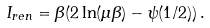<formula> <loc_0><loc_0><loc_500><loc_500>I _ { r e n } = \beta ( 2 \ln ( \mu \beta ) - \psi ( 1 / 2 ) ) \, .</formula> 